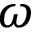Convert formula to latex. <formula><loc_0><loc_0><loc_500><loc_500>\omega</formula> 